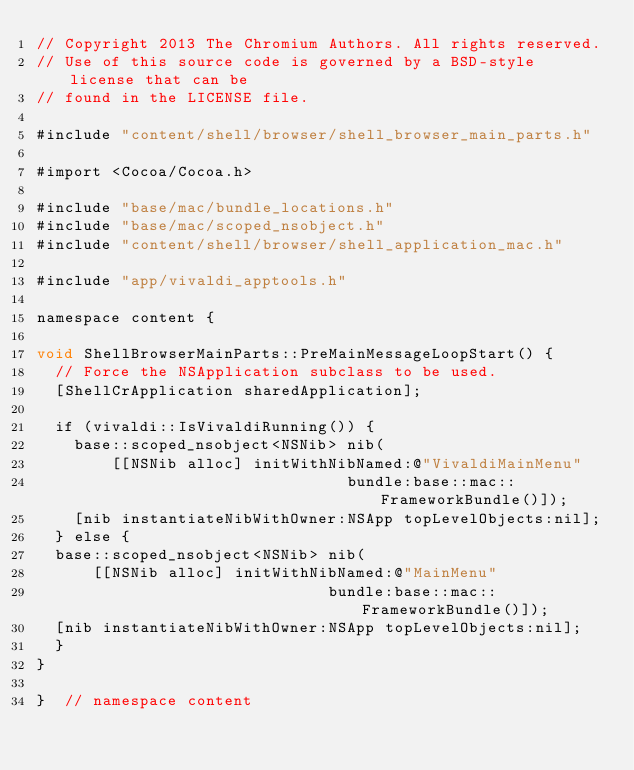Convert code to text. <code><loc_0><loc_0><loc_500><loc_500><_ObjectiveC_>// Copyright 2013 The Chromium Authors. All rights reserved.
// Use of this source code is governed by a BSD-style license that can be
// found in the LICENSE file.

#include "content/shell/browser/shell_browser_main_parts.h"

#import <Cocoa/Cocoa.h>

#include "base/mac/bundle_locations.h"
#include "base/mac/scoped_nsobject.h"
#include "content/shell/browser/shell_application_mac.h"

#include "app/vivaldi_apptools.h"

namespace content {

void ShellBrowserMainParts::PreMainMessageLoopStart() {
  // Force the NSApplication subclass to be used.
  [ShellCrApplication sharedApplication];

  if (vivaldi::IsVivaldiRunning()) {
    base::scoped_nsobject<NSNib> nib(
        [[NSNib alloc] initWithNibNamed:@"VivaldiMainMenu"
                                 bundle:base::mac::FrameworkBundle()]);
    [nib instantiateNibWithOwner:NSApp topLevelObjects:nil];
  } else {
  base::scoped_nsobject<NSNib> nib(
      [[NSNib alloc] initWithNibNamed:@"MainMenu"
                               bundle:base::mac::FrameworkBundle()]);
  [nib instantiateNibWithOwner:NSApp topLevelObjects:nil];
  }
}

}  // namespace content
</code> 